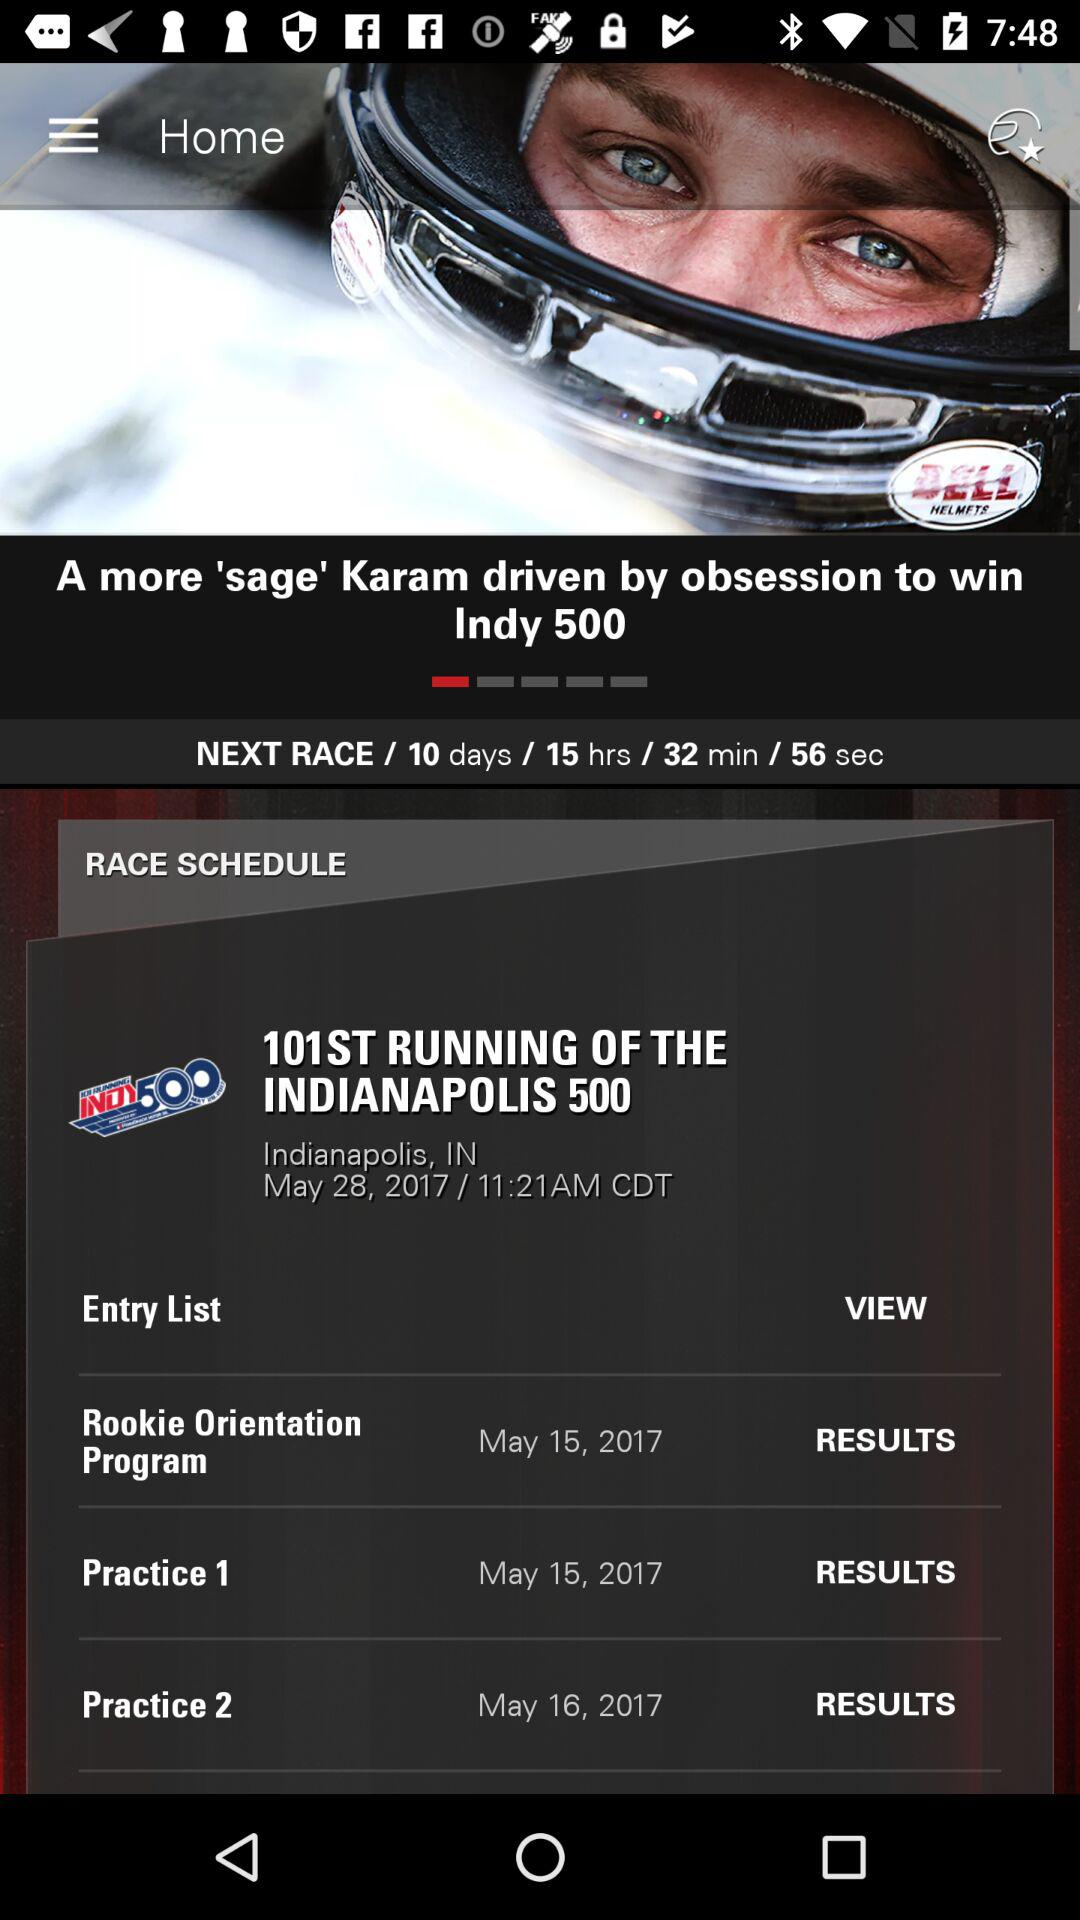When will the "Rookie Orientation Program" happen? The Rookie Orientation program will happen on May 15, 2017. 